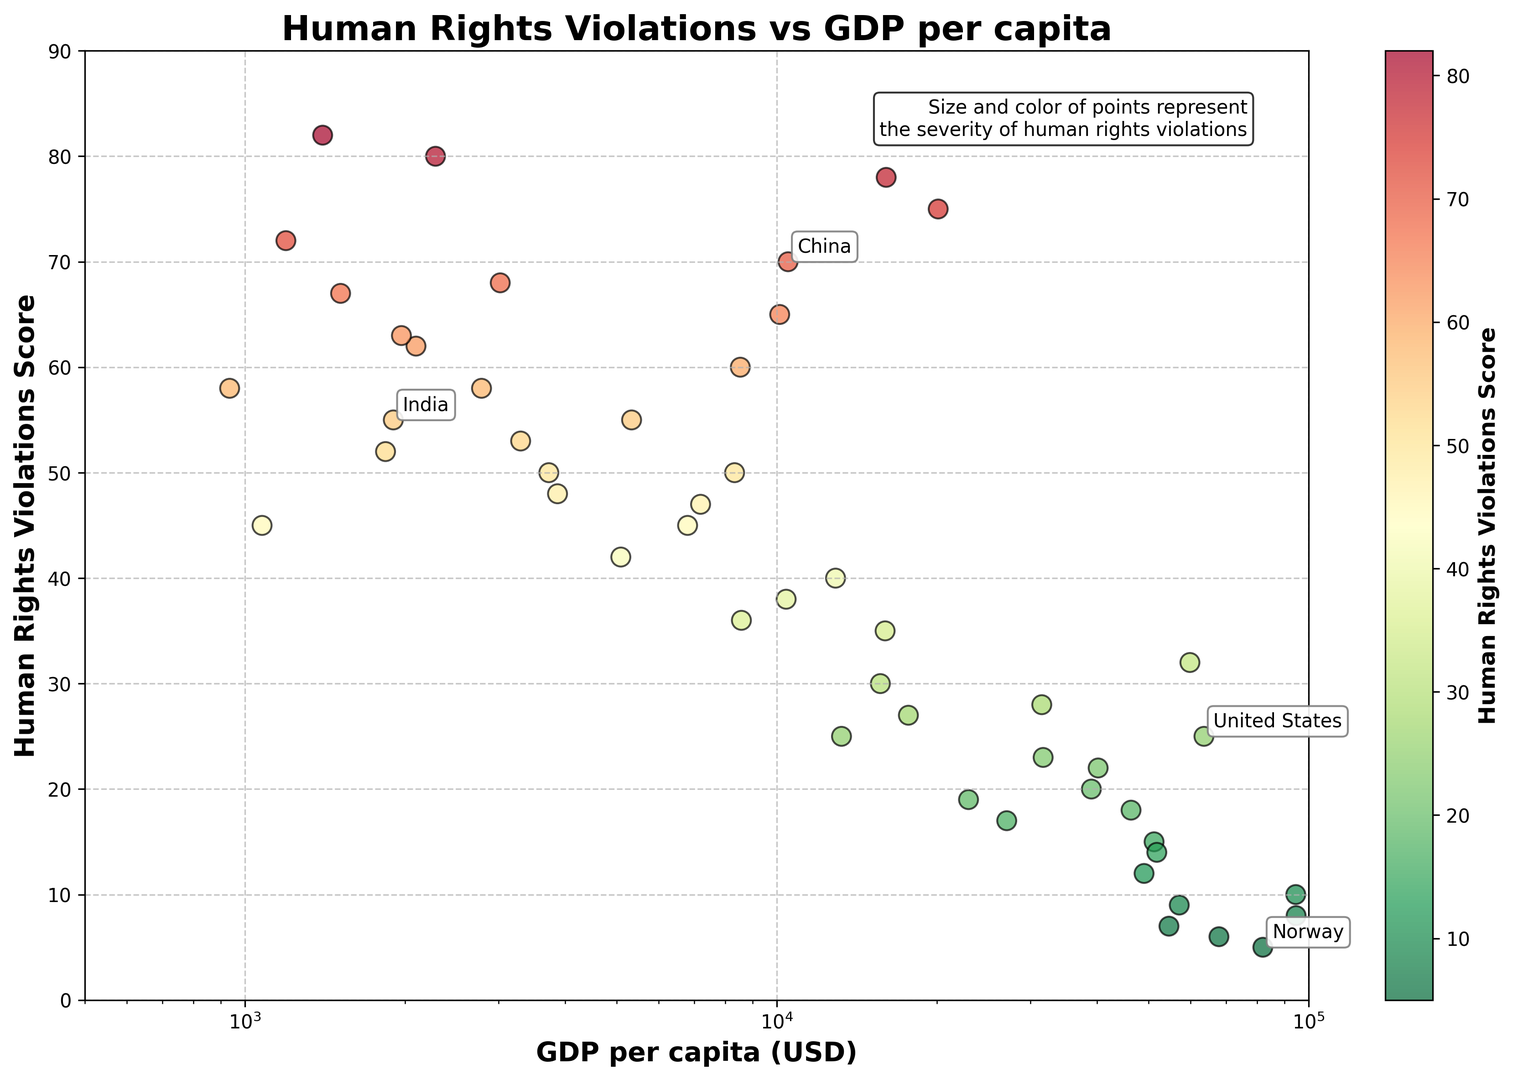What is the GDP per capita value for Norway, and where does it plot relative to the x and y axes? Norway's GDP per capita is $81,995, and its human rights violations score is 5. On the scatter plot, it lies towards the right (high GDP) and very close to the bottom (low violations score).
Answer: High GDP, Low Violations Which country has the highest human rights violations score, and what is its GDP per capita? Myanmar has the highest human rights violations score of 82, and its GDP per capita is $1,400. This is evident as the highest point on the y-axis and relatively towards the left on the x-axis.
Answer: Myanmar, $1,400 Between China and India, which country exhibits a higher human rights violations score? China has a human rights violations score of 70, while India's score is 55. This can be determined by observing their locations on the y-axis.
Answer: China Compare the GDP per capita of the United States and Japan and determine which one is higher. The GDP per capita for the United States is $63,544, and for Japan, it is $40,193. The United States has a higher GDP per capita. The corresponding points show the United States further right than Japan on the x-axis.
Answer: United States Out of the countries annotated on the plot (Norway, China, United States, India), which has the lowest GDP per capita? India's GDP per capita is the lowest among the annotated countries at $1,901. This is seen as its point is farthest left on the x-axis among the labeled ones.
Answer: India Identify the country with a GDP per capita around $20,110 and its corresponding human rights violations score. Saudi Arabia has a GDP per capita around $20,110, and its human rights violations score is 75. This can be identified by matching its point to the given x-axis value.
Answer: Saudi Arabia, 75 What is the GDP per capita range of countries with a human rights violations score below 10? Countries with a human rights violations score below 10 include Norway, Switzerland, Sweden, Denmark, and the Netherlands. Their GDP per capita ranges from $54,608 for Sweden to $94,696 for Switzerland.
Answer: $54,608 - $94,696 Which country with a GDP less than $10,000 shows the highest human rights violations score? Myanmar, with a GDP per capita of $1,400, shows the highest human rights violations score of 82 for countries with GDP less than $10,000. This is identified as the highest point in the leftmost section of the plot.
Answer: Myanmar Determine whether there is a visual trend in the scatter plot regarding the relationship between GDP per capita and human rights violations score. There appears to be a descending trend where countries with higher GDP per capita generally show lower human rights violations scores. This is identified by most points with high GDP being lower on the y-axis.
Answer: Descending trend Is there any country with a GDP per capita around $50,000 and a human rights violations score around 14? Australia exhibits a GDP per capita around $51,812 with a human rights violations score of 14. This is verifiable by locating the approximate values on both axes.
Answer: Australia 